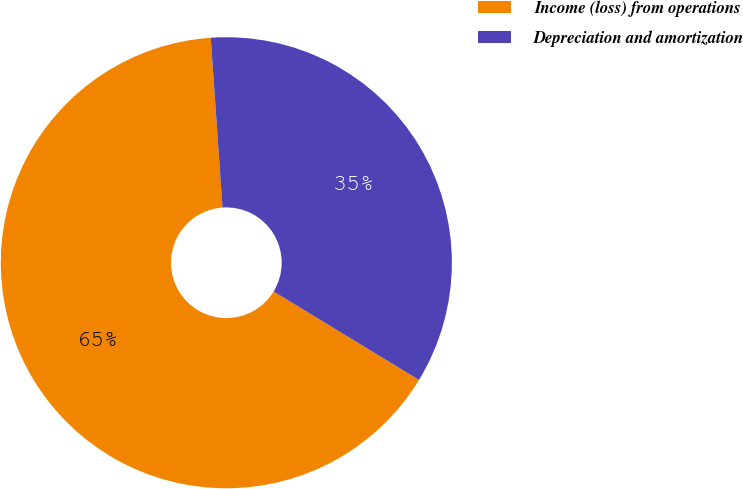Convert chart. <chart><loc_0><loc_0><loc_500><loc_500><pie_chart><fcel>Income (loss) from operations<fcel>Depreciation and amortization<nl><fcel>65.2%<fcel>34.8%<nl></chart> 